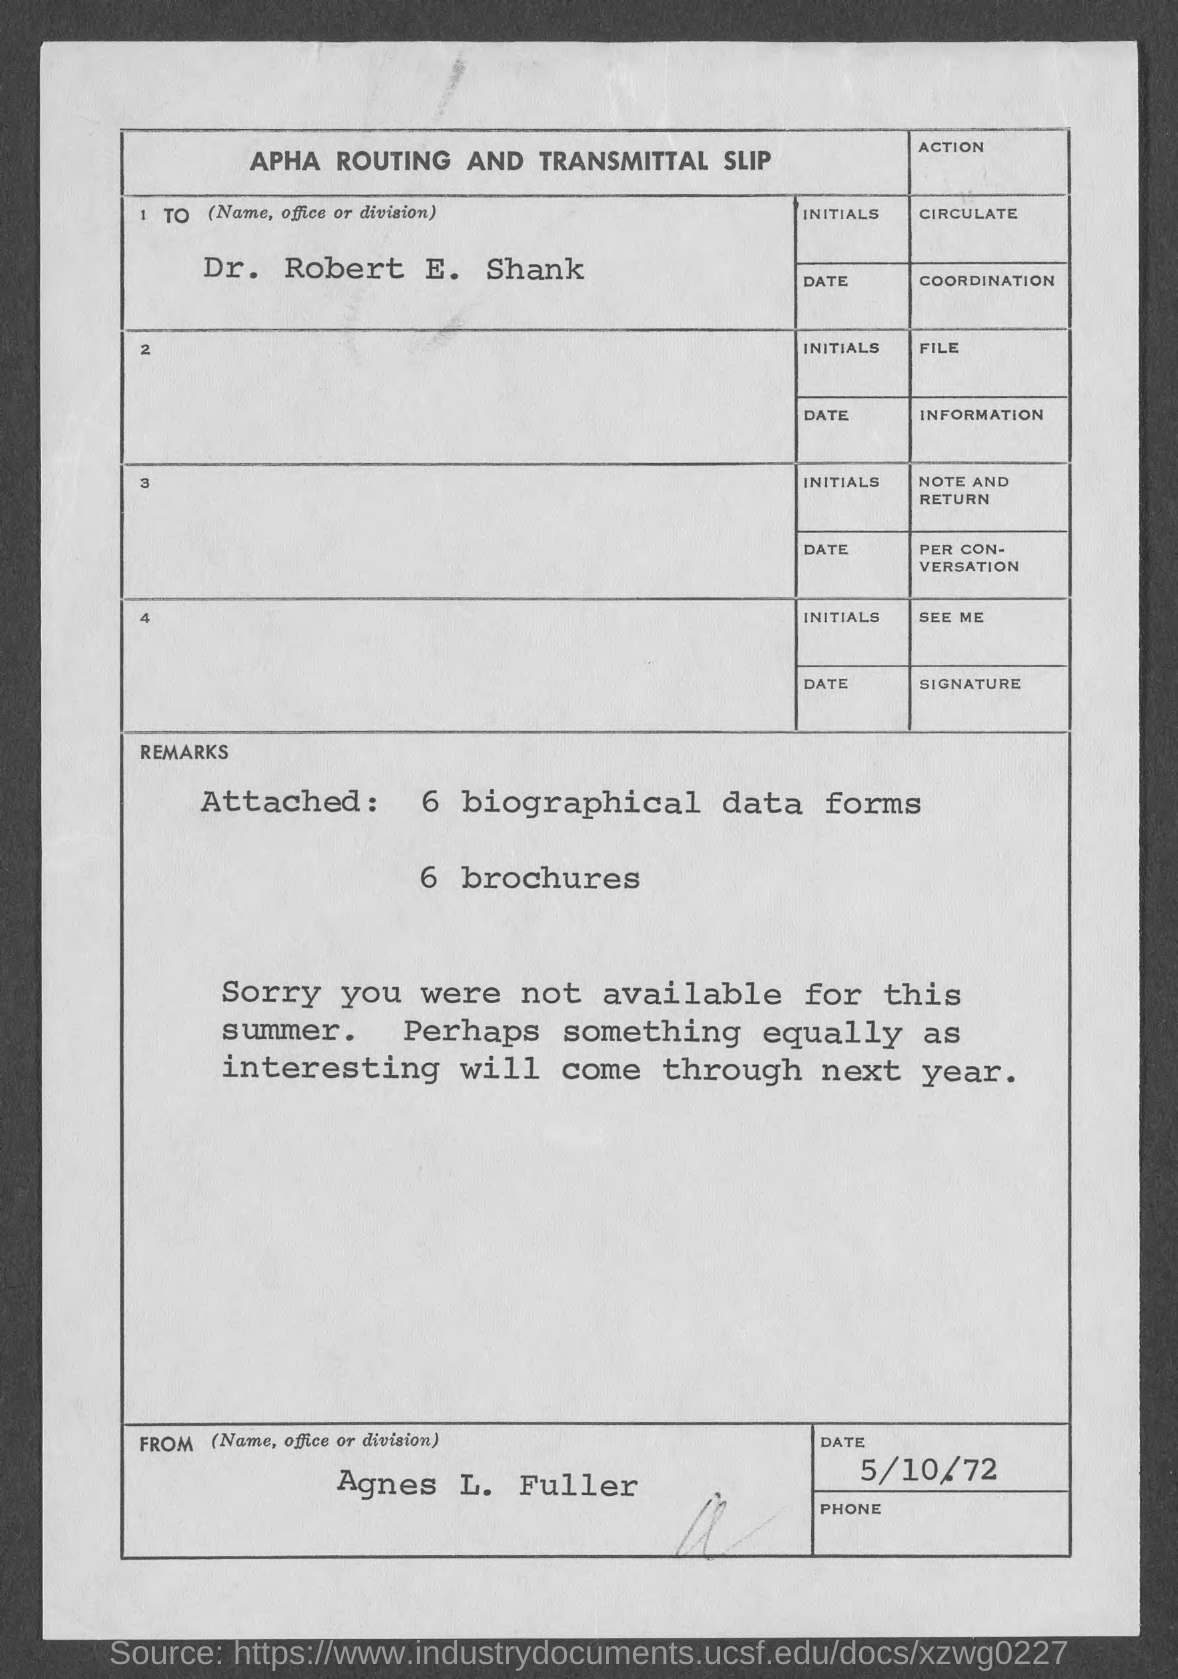What is the Name?
Your answer should be very brief. Dr. Robert E. Shank. How many biographical data forms are attached?
Give a very brief answer. 6. How many Brochures are attached?
Keep it short and to the point. 6 brochures. When was he not available?
Ensure brevity in your answer.  Summer. Who is this from?
Keep it short and to the point. Agnes L. Fuller. What is the date on the document?
Your answer should be very brief. 5/10/72. 